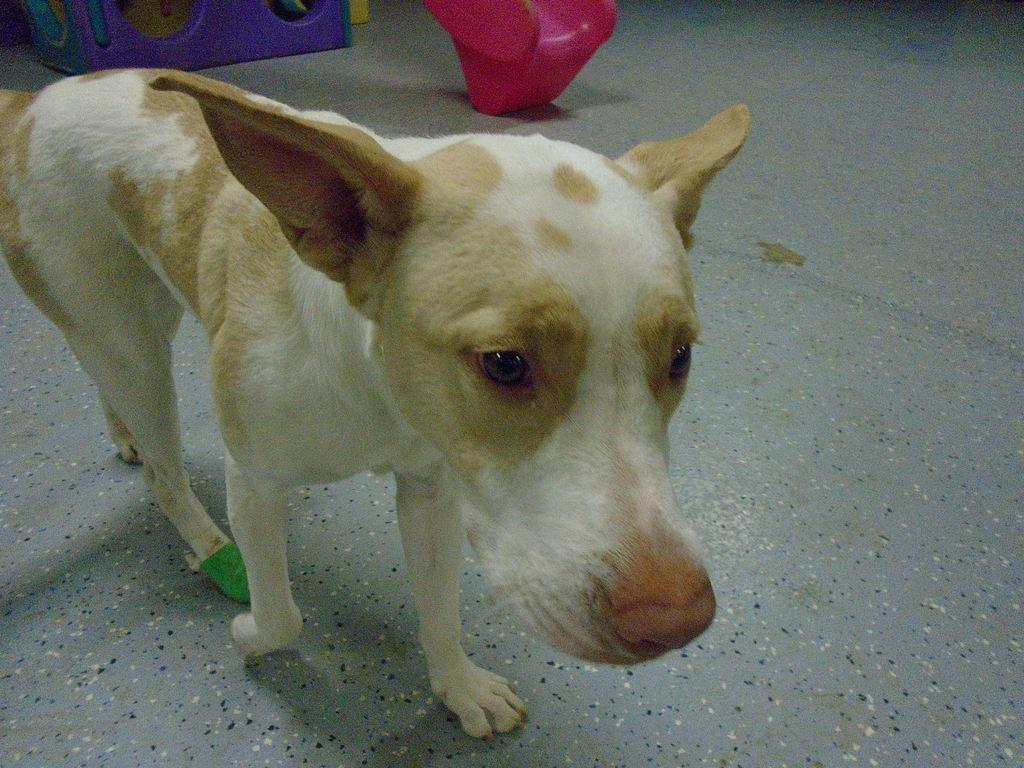Please provide a concise description of this image. In this image we can see a dog is standing on the floor. At the top of the image pink and blue color plastic things are present. 